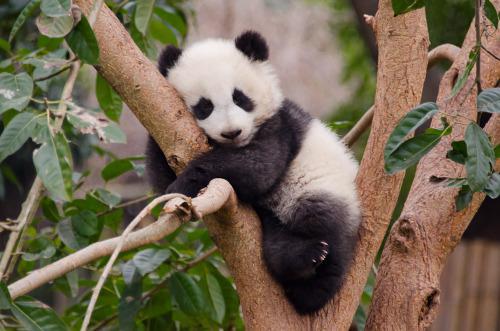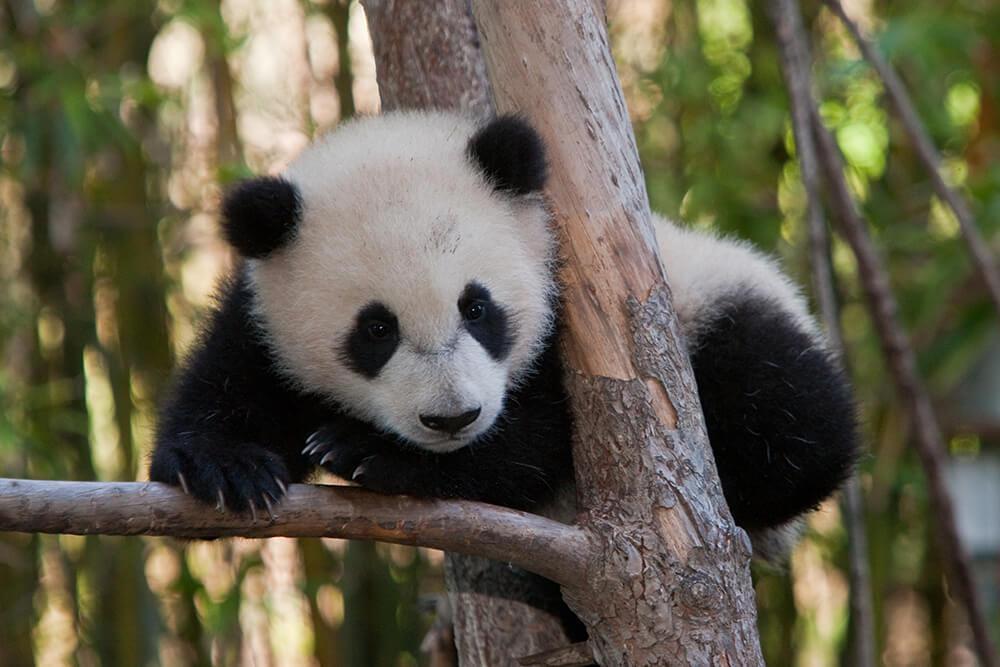The first image is the image on the left, the second image is the image on the right. Given the left and right images, does the statement "The panda on the left is in a tree." hold true? Answer yes or no. Yes. The first image is the image on the left, the second image is the image on the right. Examine the images to the left and right. Is the description "An image includes a panda at least partly lying on its back on green ground." accurate? Answer yes or no. No. The first image is the image on the left, the second image is the image on the right. Examine the images to the left and right. Is the description "A panda is playing with another panda in at least one of the images." accurate? Answer yes or no. No. The first image is the image on the left, the second image is the image on the right. Assess this claim about the two images: "An image shows a panda on its back with a smaller panda on top of it.". Correct or not? Answer yes or no. No. 